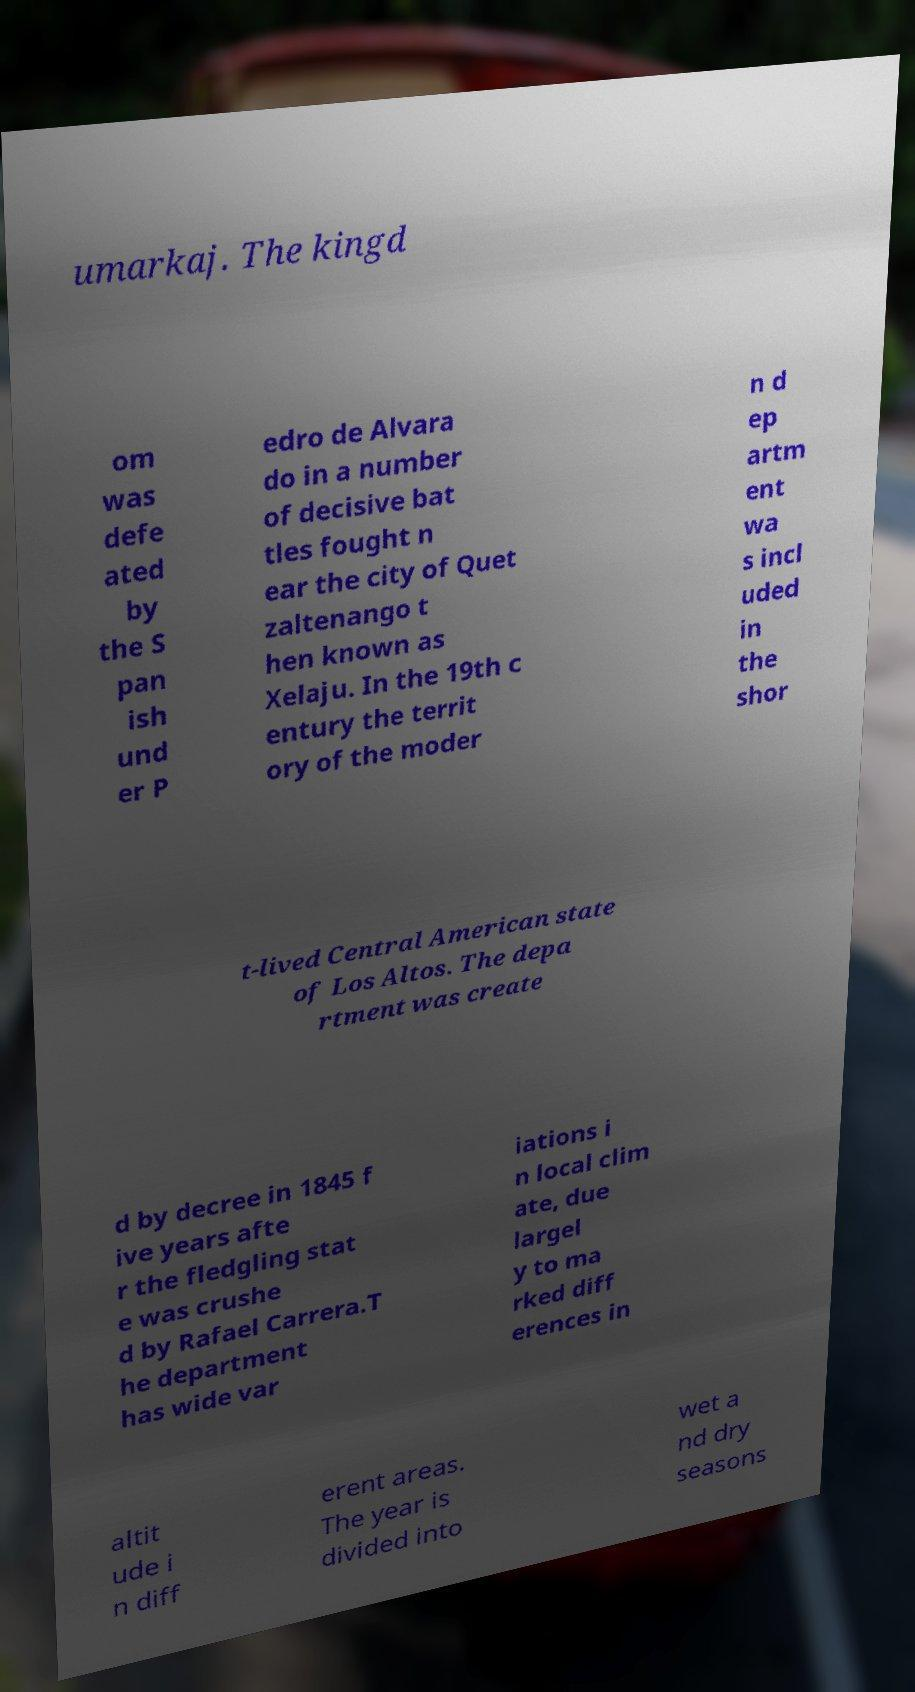There's text embedded in this image that I need extracted. Can you transcribe it verbatim? umarkaj. The kingd om was defe ated by the S pan ish und er P edro de Alvara do in a number of decisive bat tles fought n ear the city of Quet zaltenango t hen known as Xelaju. In the 19th c entury the territ ory of the moder n d ep artm ent wa s incl uded in the shor t-lived Central American state of Los Altos. The depa rtment was create d by decree in 1845 f ive years afte r the fledgling stat e was crushe d by Rafael Carrera.T he department has wide var iations i n local clim ate, due largel y to ma rked diff erences in altit ude i n diff erent areas. The year is divided into wet a nd dry seasons 